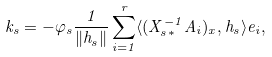<formula> <loc_0><loc_0><loc_500><loc_500>k _ { s } = - \varphi _ { s } \frac { 1 } { \| h _ { s } \| } \sum _ { i = 1 } ^ { r } \langle ( X _ { s \ast } ^ { - 1 } A _ { i } ) _ { x } , h _ { s } \rangle e _ { i } ,</formula> 